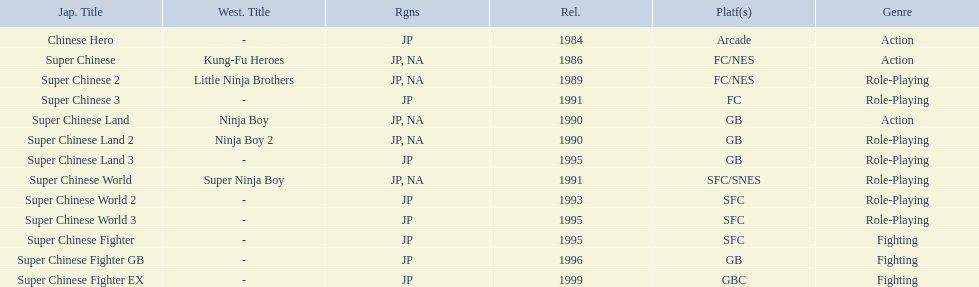Super ninja world was released in what countries? JP, NA. What was the original name for this title? Super Chinese World. 